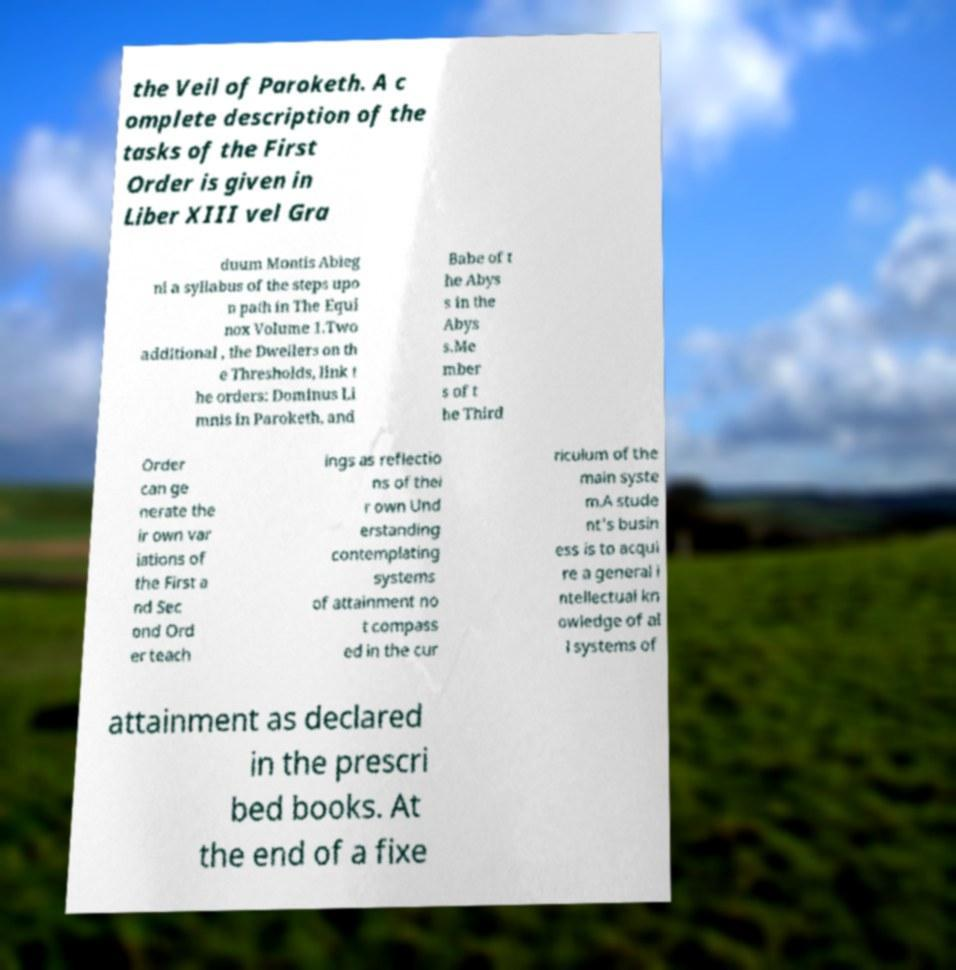Could you assist in decoding the text presented in this image and type it out clearly? the Veil of Paroketh. A c omplete description of the tasks of the First Order is given in Liber XIII vel Gra duum Montis Abieg ni a syllabus of the steps upo n path in The Equi nox Volume 1.Two additional , the Dwellers on th e Thresholds, link t he orders: Dominus Li mnis in Paroketh, and Babe of t he Abys s in the Abys s.Me mber s of t he Third Order can ge nerate the ir own var iations of the First a nd Sec ond Ord er teach ings as reflectio ns of thei r own Und erstanding contemplating systems of attainment no t compass ed in the cur riculum of the main syste m.A stude nt's busin ess is to acqui re a general i ntellectual kn owledge of al l systems of attainment as declared in the prescri bed books. At the end of a fixe 